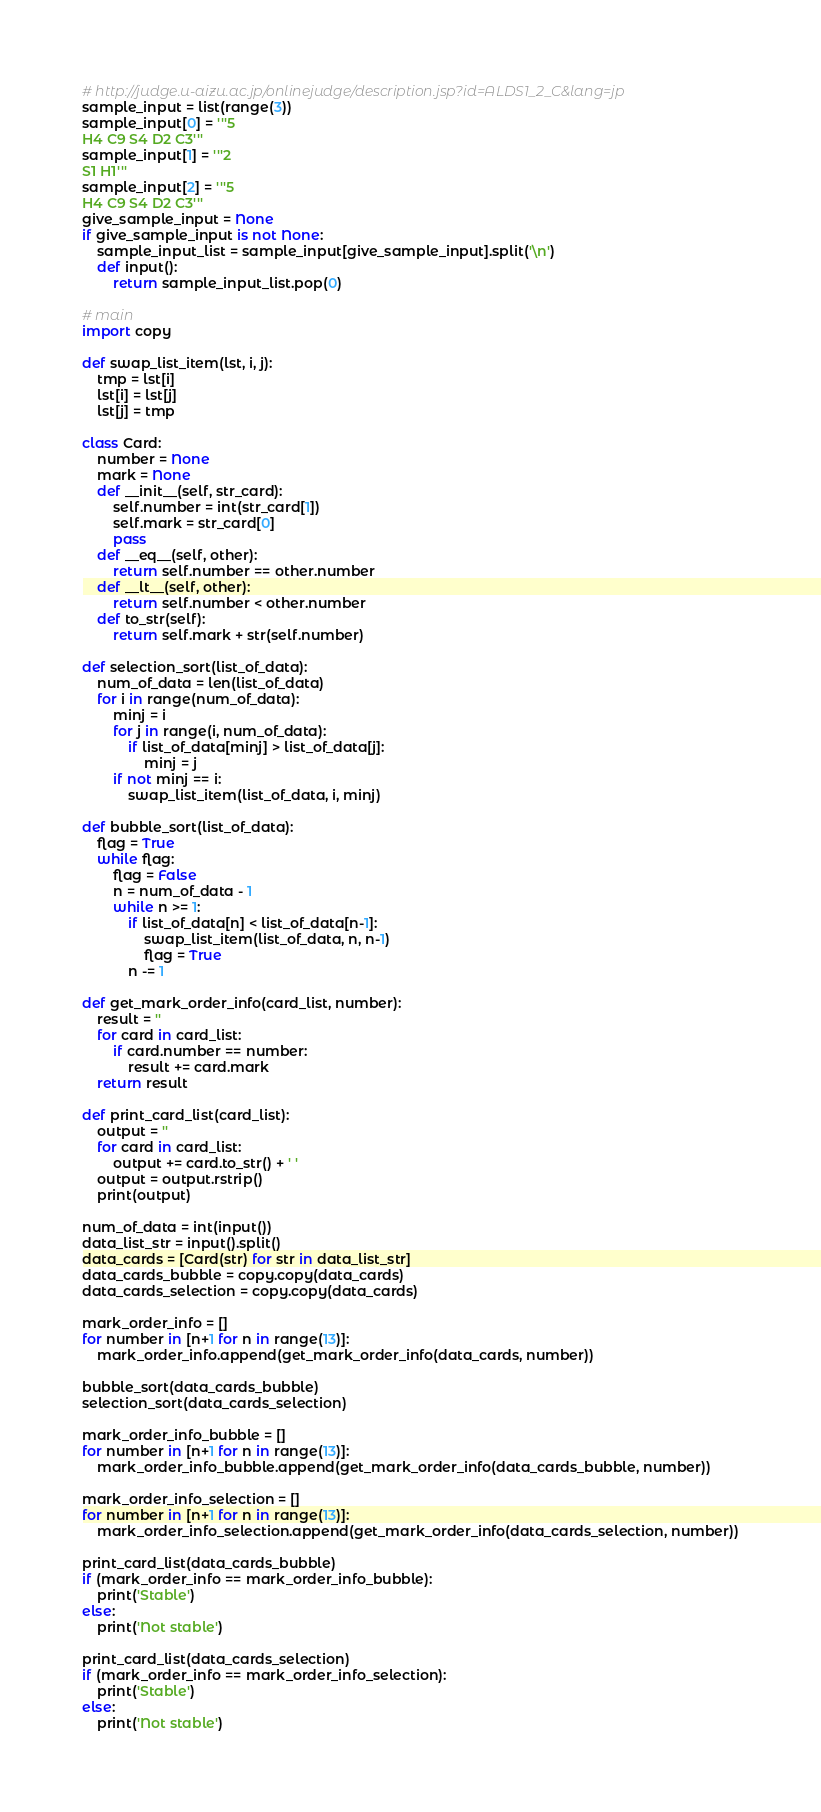Convert code to text. <code><loc_0><loc_0><loc_500><loc_500><_Python_># http://judge.u-aizu.ac.jp/onlinejudge/description.jsp?id=ALDS1_2_C&lang=jp
sample_input = list(range(3))
sample_input[0] = '''5
H4 C9 S4 D2 C3'''
sample_input[1] = '''2
S1 H1'''
sample_input[2] = '''5
H4 C9 S4 D2 C3'''
give_sample_input = None
if give_sample_input is not None:
    sample_input_list = sample_input[give_sample_input].split('\n')
    def input():
        return sample_input_list.pop(0)
        
# main
import copy

def swap_list_item(lst, i, j):
    tmp = lst[i]
    lst[i] = lst[j]
    lst[j] = tmp
    
class Card:
    number = None
    mark = None
    def __init__(self, str_card):
        self.number = int(str_card[1])
        self.mark = str_card[0]
        pass
    def __eq__(self, other):
        return self.number == other.number
    def __lt__(self, other):
        return self.number < other.number
    def to_str(self):
        return self.mark + str(self.number)

def selection_sort(list_of_data):
    num_of_data = len(list_of_data)
    for i in range(num_of_data):
        minj = i
        for j in range(i, num_of_data):
            if list_of_data[minj] > list_of_data[j]:
                minj = j
        if not minj == i:
            swap_list_item(list_of_data, i, minj)
            
def bubble_sort(list_of_data):
    flag = True
    while flag:
        flag = False
        n = num_of_data - 1
        while n >= 1:
            if list_of_data[n] < list_of_data[n-1]:
                swap_list_item(list_of_data, n, n-1)
                flag = True
            n -= 1
        
def get_mark_order_info(card_list, number):
    result = ''
    for card in card_list:
        if card.number == number:
            result += card.mark
    return result

def print_card_list(card_list):
    output = ''
    for card in card_list:
        output += card.to_str() + ' '
    output = output.rstrip()
    print(output)

num_of_data = int(input())
data_list_str = input().split()
data_cards = [Card(str) for str in data_list_str]
data_cards_bubble = copy.copy(data_cards)
data_cards_selection = copy.copy(data_cards)

mark_order_info = []
for number in [n+1 for n in range(13)]:
    mark_order_info.append(get_mark_order_info(data_cards, number))
    
bubble_sort(data_cards_bubble)
selection_sort(data_cards_selection)

mark_order_info_bubble = []
for number in [n+1 for n in range(13)]:
    mark_order_info_bubble.append(get_mark_order_info(data_cards_bubble, number))

mark_order_info_selection = []
for number in [n+1 for n in range(13)]:
    mark_order_info_selection.append(get_mark_order_info(data_cards_selection, number))
    
print_card_list(data_cards_bubble)
if (mark_order_info == mark_order_info_bubble):
    print('Stable')
else:
    print('Not stable')
    
print_card_list(data_cards_selection)
if (mark_order_info == mark_order_info_selection):
    print('Stable')
else:
    print('Not stable')</code> 